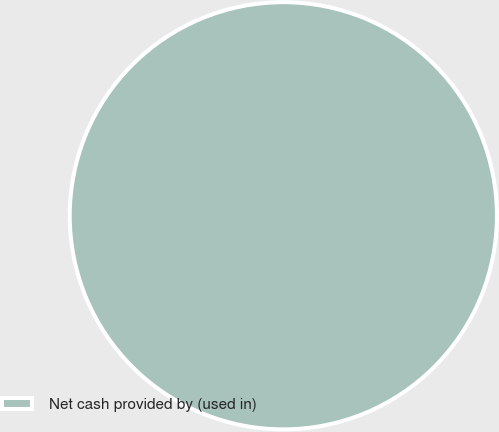Convert chart to OTSL. <chart><loc_0><loc_0><loc_500><loc_500><pie_chart><fcel>Net cash provided by (used in)<nl><fcel>100.0%<nl></chart> 